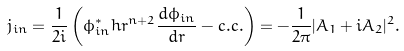<formula> <loc_0><loc_0><loc_500><loc_500>j _ { i n } = \frac { 1 } { 2 i } \left ( \phi _ { i n } ^ { \ast } h r ^ { n + 2 } \frac { d \phi _ { i n } } { d r } - c . c . \right ) = - \frac { 1 } { 2 \pi } | A _ { 1 } + i A _ { 2 } | ^ { 2 } .</formula> 